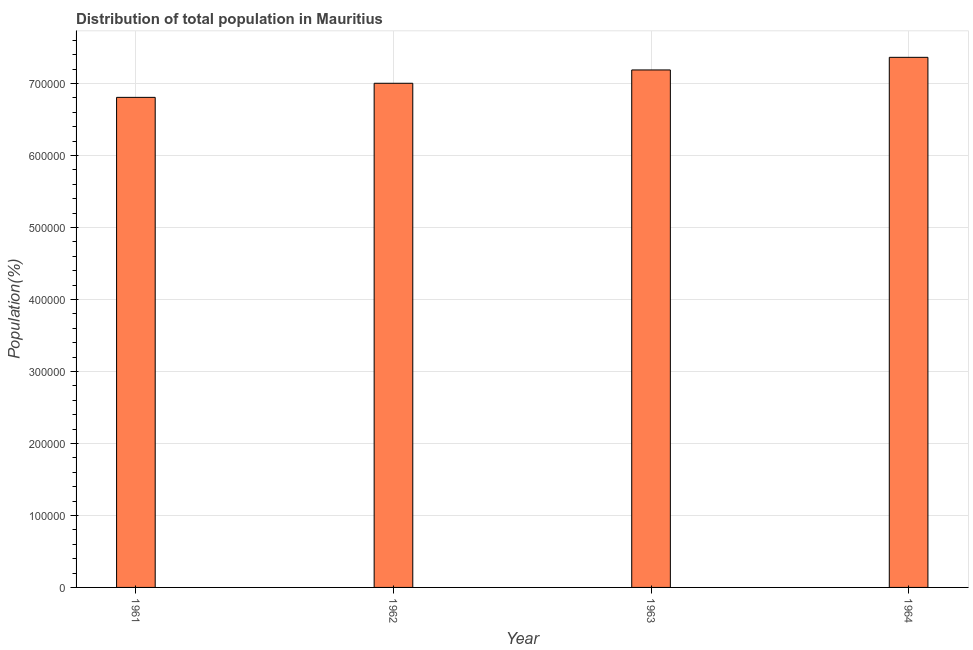Does the graph contain any zero values?
Ensure brevity in your answer.  No. What is the title of the graph?
Offer a very short reply. Distribution of total population in Mauritius . What is the label or title of the X-axis?
Provide a short and direct response. Year. What is the label or title of the Y-axis?
Offer a terse response. Population(%). What is the population in 1961?
Your answer should be compact. 6.81e+05. Across all years, what is the maximum population?
Provide a succinct answer. 7.36e+05. Across all years, what is the minimum population?
Provide a succinct answer. 6.81e+05. In which year was the population maximum?
Provide a short and direct response. 1964. In which year was the population minimum?
Your answer should be compact. 1961. What is the sum of the population?
Provide a succinct answer. 2.84e+06. What is the difference between the population in 1962 and 1964?
Make the answer very short. -3.60e+04. What is the average population per year?
Provide a short and direct response. 7.09e+05. What is the median population?
Ensure brevity in your answer.  7.10e+05. In how many years, is the population greater than 420000 %?
Your answer should be very brief. 4. Do a majority of the years between 1961 and 1962 (inclusive) have population greater than 720000 %?
Your answer should be compact. No. What is the ratio of the population in 1962 to that in 1964?
Your answer should be very brief. 0.95. Is the population in 1961 less than that in 1963?
Ensure brevity in your answer.  Yes. What is the difference between the highest and the second highest population?
Give a very brief answer. 1.75e+04. Is the sum of the population in 1961 and 1964 greater than the maximum population across all years?
Keep it short and to the point. Yes. What is the difference between the highest and the lowest population?
Provide a succinct answer. 5.56e+04. How many bars are there?
Your answer should be compact. 4. Are all the bars in the graph horizontal?
Make the answer very short. No. What is the difference between two consecutive major ticks on the Y-axis?
Offer a very short reply. 1.00e+05. What is the Population(%) in 1961?
Offer a terse response. 6.81e+05. What is the Population(%) in 1962?
Keep it short and to the point. 7.00e+05. What is the Population(%) of 1963?
Give a very brief answer. 7.19e+05. What is the Population(%) in 1964?
Provide a succinct answer. 7.36e+05. What is the difference between the Population(%) in 1961 and 1962?
Provide a short and direct response. -1.96e+04. What is the difference between the Population(%) in 1961 and 1963?
Ensure brevity in your answer.  -3.81e+04. What is the difference between the Population(%) in 1961 and 1964?
Your answer should be very brief. -5.56e+04. What is the difference between the Population(%) in 1962 and 1963?
Provide a succinct answer. -1.85e+04. What is the difference between the Population(%) in 1962 and 1964?
Keep it short and to the point. -3.60e+04. What is the difference between the Population(%) in 1963 and 1964?
Ensure brevity in your answer.  -1.75e+04. What is the ratio of the Population(%) in 1961 to that in 1963?
Your answer should be compact. 0.95. What is the ratio of the Population(%) in 1961 to that in 1964?
Ensure brevity in your answer.  0.92. What is the ratio of the Population(%) in 1962 to that in 1964?
Your response must be concise. 0.95. 